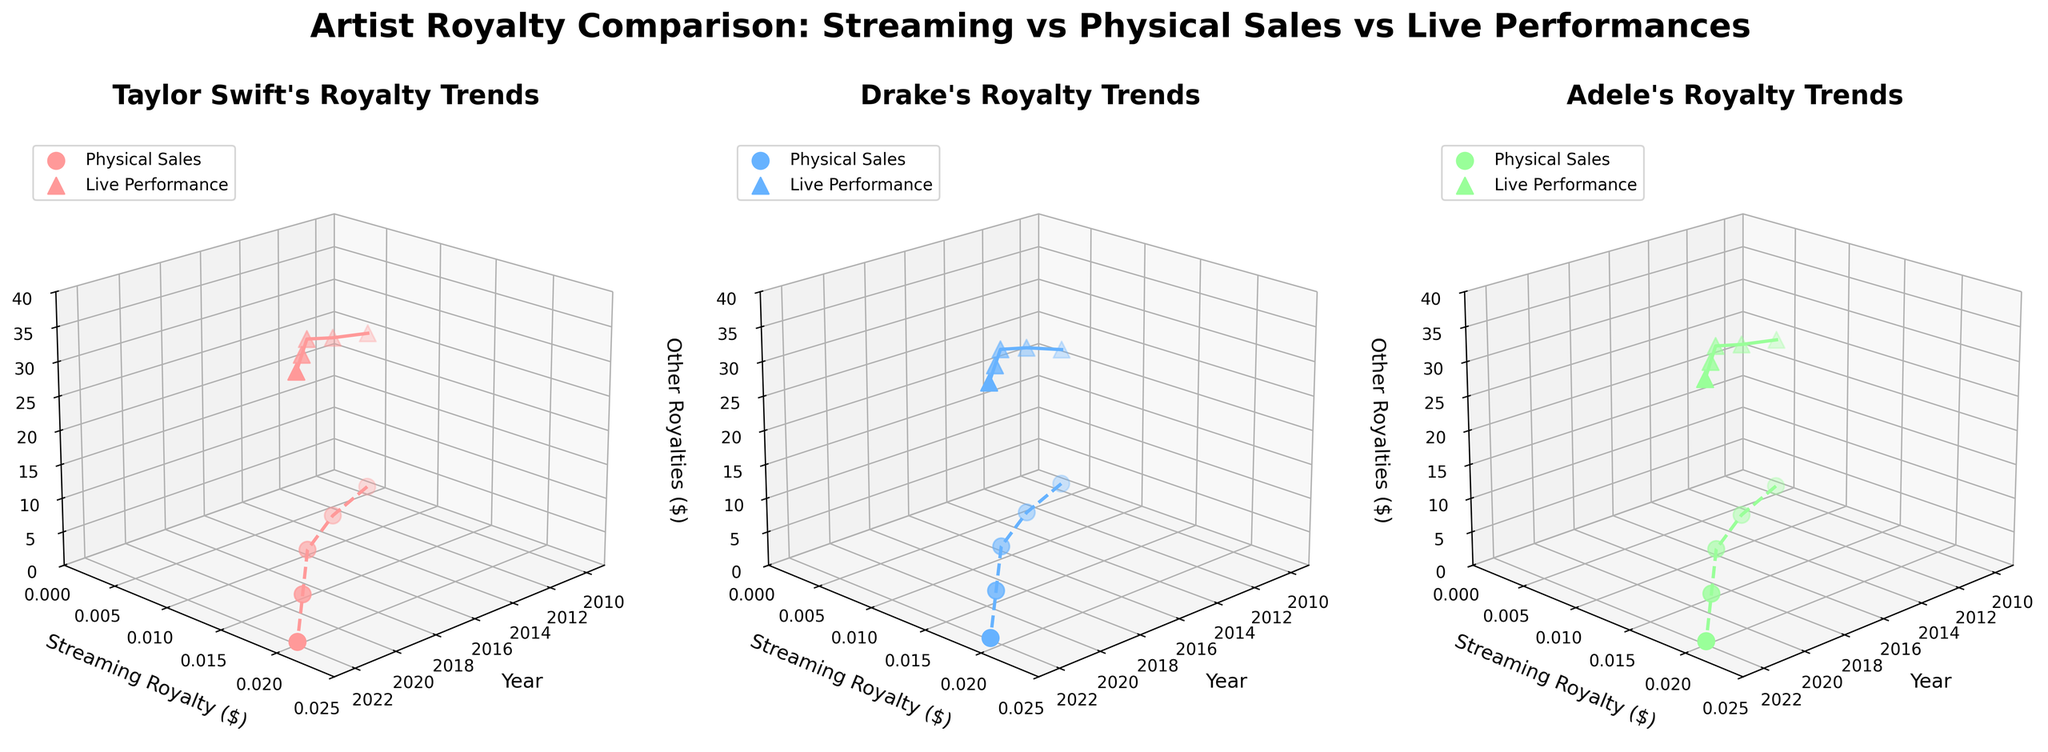What is the title of the figure? The title is usually located at the top of the figure and provides an overview of what the figure represents.
Answer: Artist Royalty Comparison: Streaming vs Physical Sales vs Live Performances Which artist has the highest streaming royalty in 2022? To find this, we look at the data points corresponding to 2022 on the y-axis for each artist and identify the highest value.
Answer: Taylor Swift and Adele What is the trend of physical sales royalties for Drake from 2010 to 2022? From the subplot for Drake, observe the data points for the physical sales royalties (marked by 'o') over the years. The value decreases from 1.1 in 2010 to 0.3 in 2022.
Answer: Decreasing Which type of royalty has the highest value for Adele in 2019? In Adele's subplot, compare the values of the streaming royalty, physical sales royalty, and live performance royalty in 2019. The live performance royalty (marked by '^') has the highest value.
Answer: Live Performance Royalty How does the 2013 streaming royalty for Taylor Swift compare to her physical sales royalty in the same year? Find the data points for 2013 in Taylor Swift's subplot. The streaming royalty is 0.007, and the physical sales royalty is 1.0, so physical sales royalty is significantly higher.
Answer: Physical sales royalty is higher What is the average streaming royalty for Drake across all years? Calculate the average by adding up Drake's streaming royalties for each year and dividing by the number of years (0.004 + 0.006 + 0.009 + 0.014 + 0.019) / 5.
Answer: 0.0104 Compare the live performance royalties of Taylor Swift and Drake in 2016. Which one is higher and by how much? In the subplots for 2016, Taylor Swift's live performance royalty is 32 and Drake's is 30. So Taylor Swift's is higher by 2.
Answer: Taylor Swift's is higher by 2 What are the axis labels in each subplot? Each subplot has three axes labeled 'Year', 'Streaming Royalty ($)', and 'Other Royalties ($)', indicating the dimensions of the data presented.
Answer: Year, Streaming Royalty ($), Other Royalties ($) How does Adele's streaming royalty growth from 2010 to 2022 compare to Taylor Swift's? Analyze the increase in streaming royalties for Adele (from 0.005 to 0.02) and for Taylor Swift (from 0.005 to 0.02). Both artists show similar growth over the years.
Answer: Similar growth What's the overall trend in live performance royalties across the three artists from 2010 to 2022? Observe the z-axis values for live performance royalties ('^' markers) across the years for all three artists. The trend shows a consistent increase over time.
Answer: Increasing 